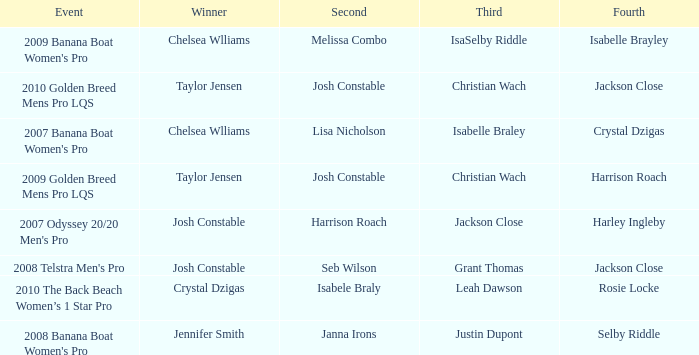Who was in Second Place with Isabelle Brayley came in Fourth? Melissa Combo. 